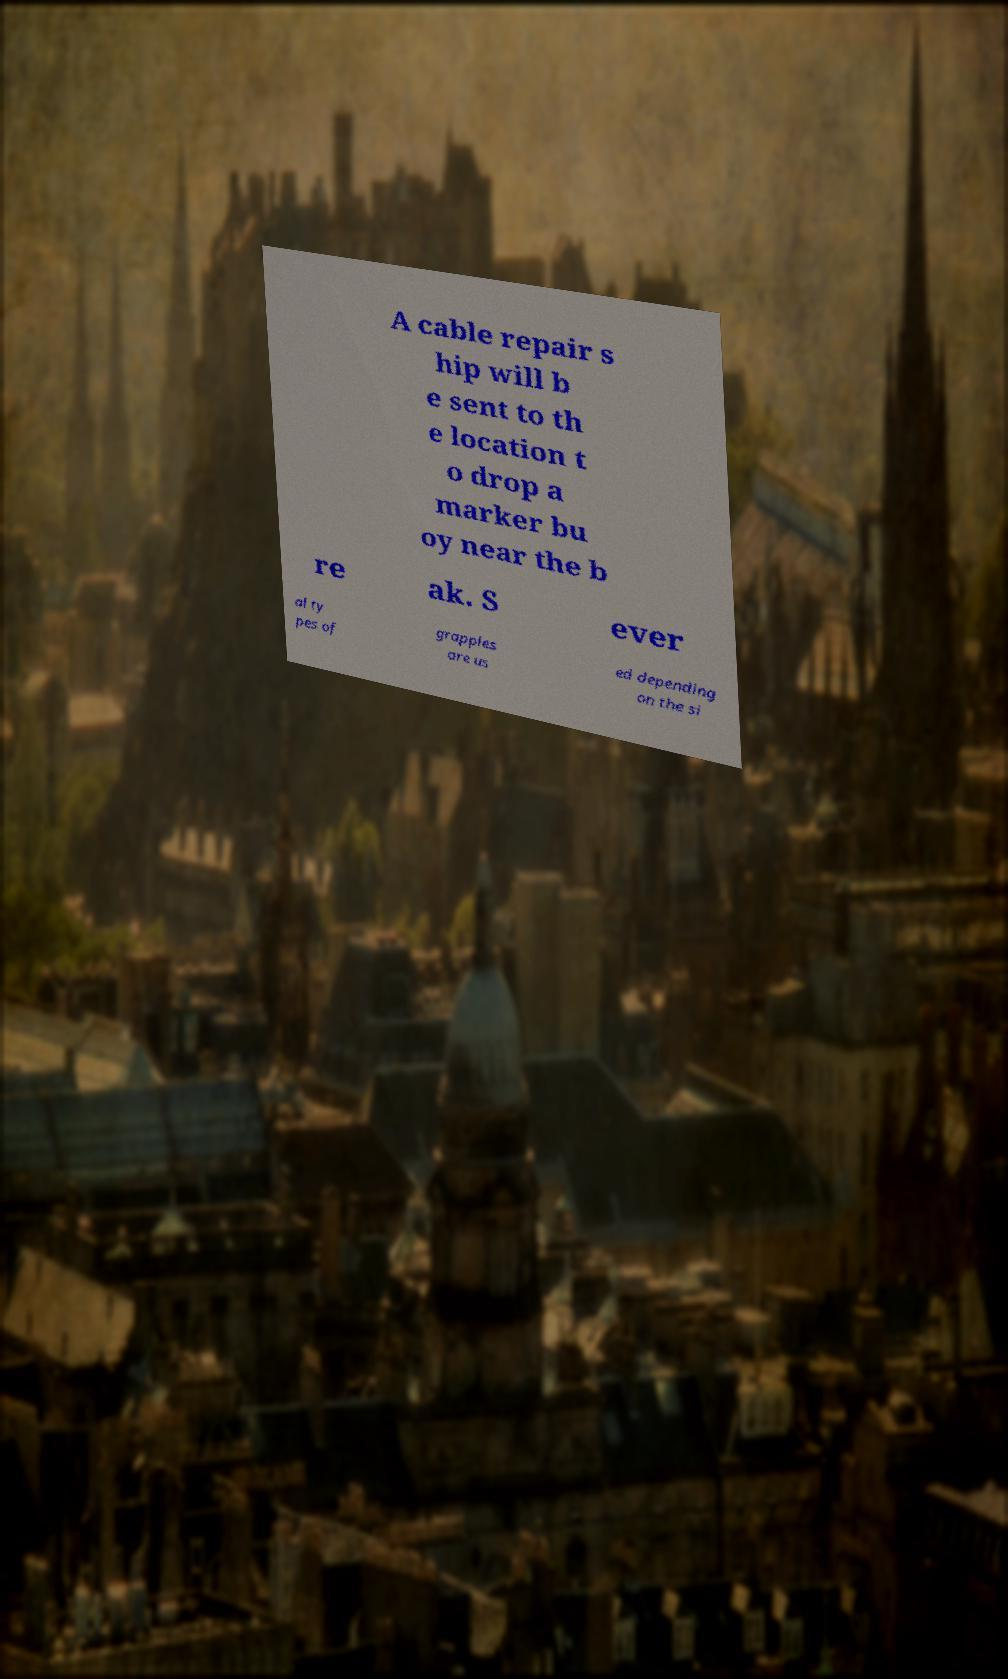Please identify and transcribe the text found in this image. A cable repair s hip will b e sent to th e location t o drop a marker bu oy near the b re ak. S ever al ty pes of grapples are us ed depending on the si 